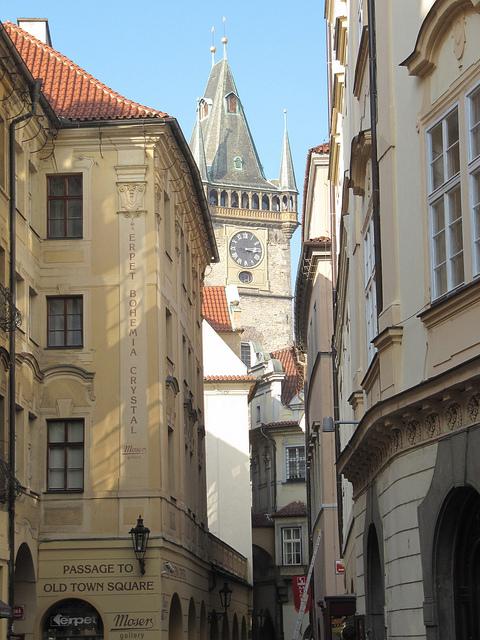Is there a traffic light?
Concise answer only. No. Are these buildings close together?
Be succinct. Yes. What time is it in the image?
Give a very brief answer. 3:15. What structure is on the front of the far building?
Answer briefly. Clock. Are there vehicles visible in the image?
Answer briefly. No. 